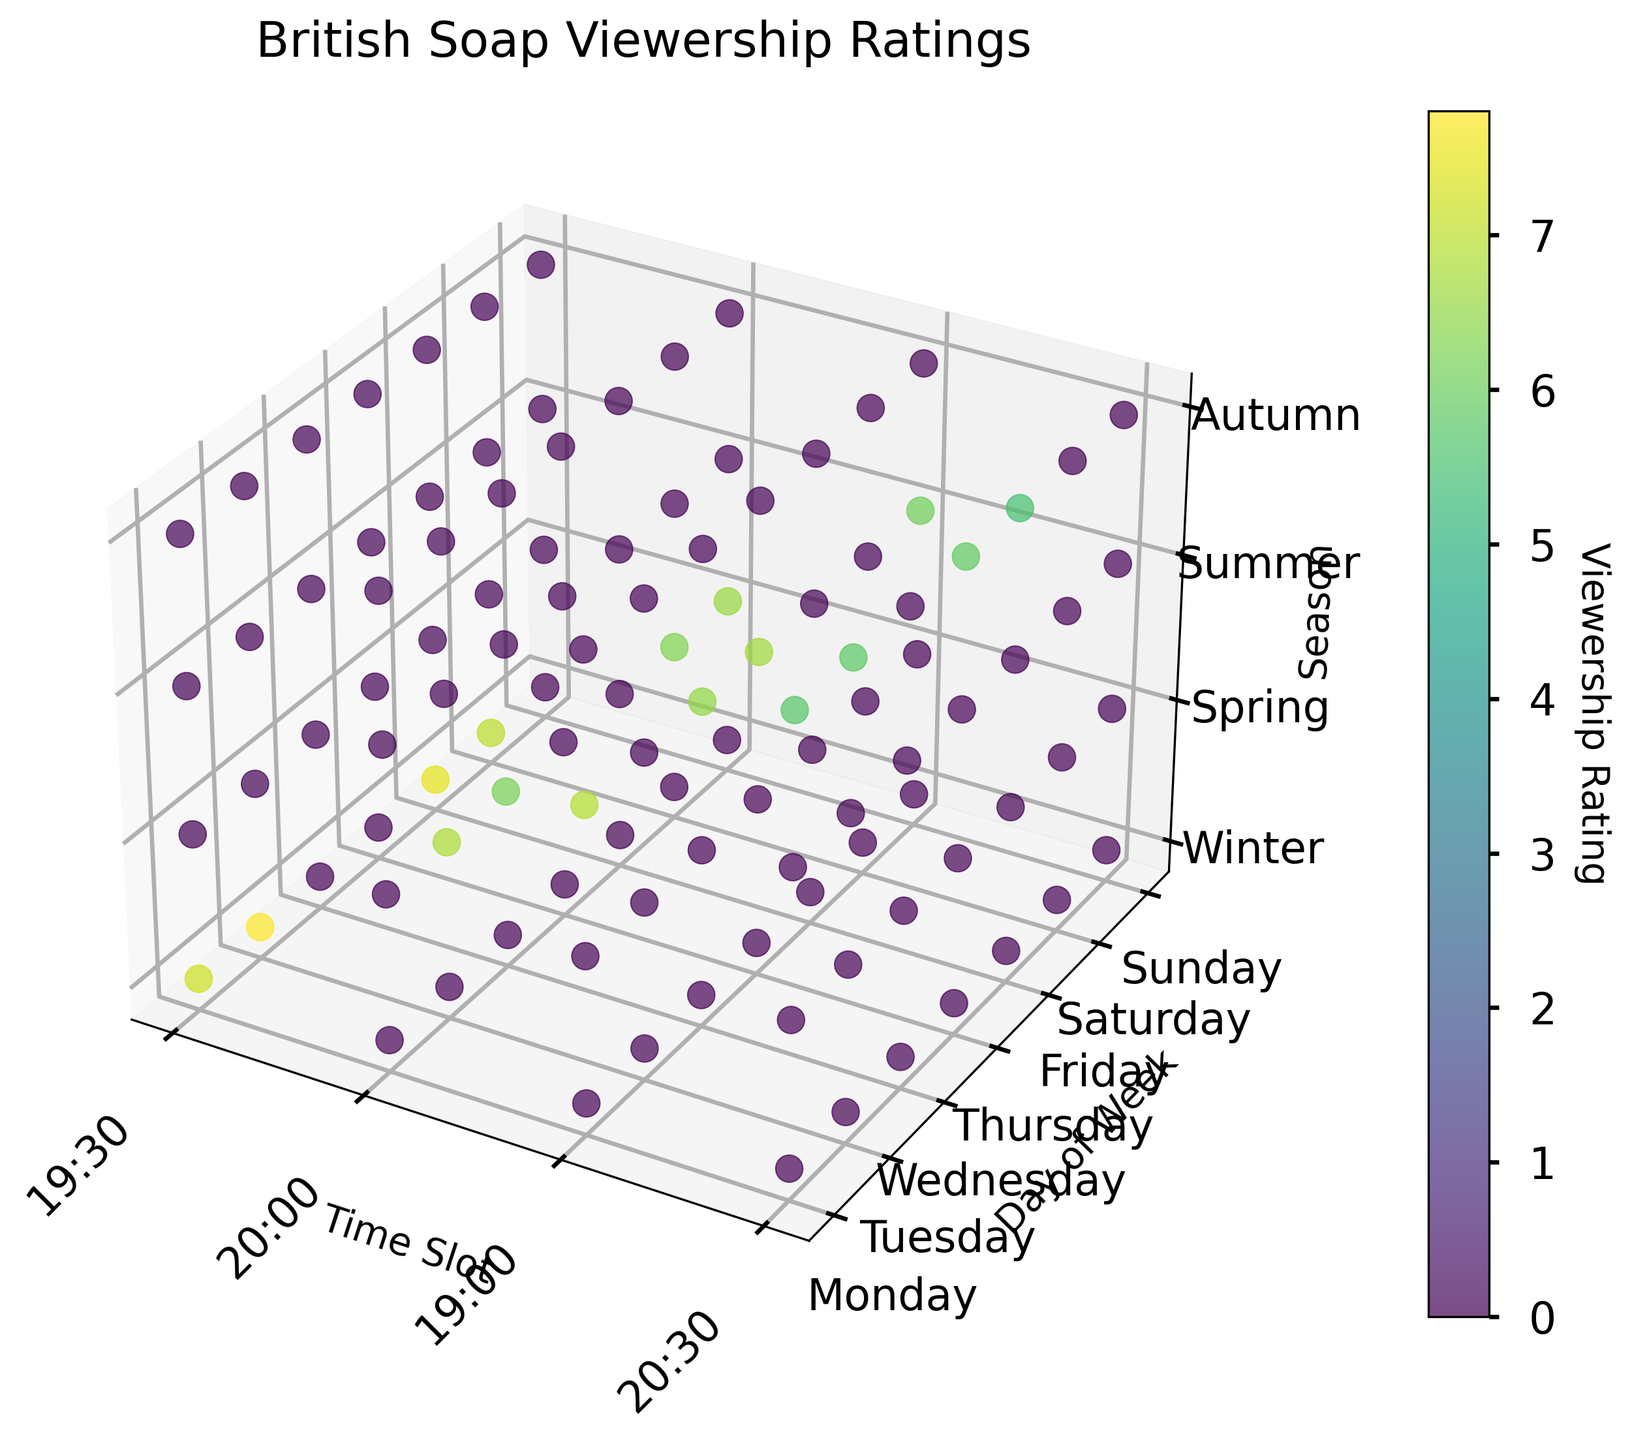what is the title of the plot? Look at the top of the plot. The title is usually placed there to describe what the plot is about.
Answer: British Soap Viewership Ratings what is the label of the x-axis? Check the axis pointing horizontally from the origin. The label describing it is written beside it.
Answer: Time Slot how many different seasons are represented in the plot? Examine the ticks along the z-axis for the number of distinct labels.
Answer: Four which soap has the highest viewership rating on a Wednesday in Spring for the age group 18-34? Locate the point along the y-axis for Wednesday, the z-axis for Spring, and the x-axis for the corresponding time slots. Identify the soap with the highest value in the scatter points for the age group 18-34.
Answer: EastEnders during which time and day is the highest viewership rating observed? Compare all the scatter points to find the one with the highest color intensity, and note the corresponding time and day axes labels.
Answer: 19:30, Tuesday what is the average viewership rating for 'Coronation Street' in Winter? Identify and note down all 'Coronation Street' ratings during Winter, then calculate their average. There are ratings at 19:30 Monday, 19:30 Friday, and 19:30 Tuesday. Sum these and divide by 3.
Answer: (7.2 + 7.5 + 7.8) / 3 = 7.5 which age group has the lowest viewership rating for 'Hollyoaks' in Autumn? Locate the scatter points for 'Hollyoaks' in Autumn along the z-axis. Identify the points with the lowest value by comparing the color intensities.
Answer: 55+ how does the viewership rating for 'EastEnders' during Spring compare from Tuesday to Sunday? Locate the scatter points for 'EastEnders' during Spring on Tuesday and Sunday, and compare the numerical values associated with each point.
Answer: Tuesday: 6.8, Sunday: 6.6; Tuesday > Sunday what is the range of viewership ratings observed in Summer across all soaps? Identify the highest and lowest data points on the z-axis for Summer. Subtract the lowest from the highest rating.
Answer: 6.9 - 6.1 = 0.8 which day has the most consistent viewership rating across all soaps? Compare the variation in ratings for each day by observing the scatter points along the y-axis and checking for the smallest difference between the maximum and minimum ratings within a day.
Answer: Wednesday 